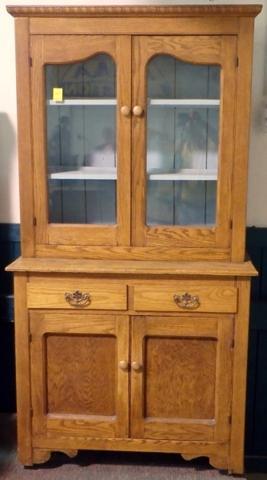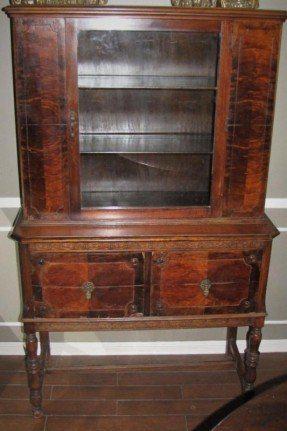The first image is the image on the left, the second image is the image on the right. Assess this claim about the two images: "There are two glass doors in the image on the left.". Correct or not? Answer yes or no. Yes. 